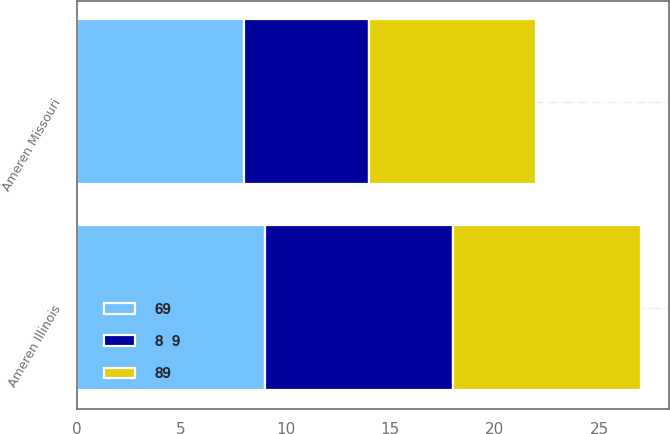<chart> <loc_0><loc_0><loc_500><loc_500><stacked_bar_chart><ecel><fcel>Ameren Missouri<fcel>Ameren Illinois<nl><fcel>69<fcel>8<fcel>9<nl><fcel>89<fcel>8<fcel>9<nl><fcel>8  9<fcel>6<fcel>9<nl></chart> 